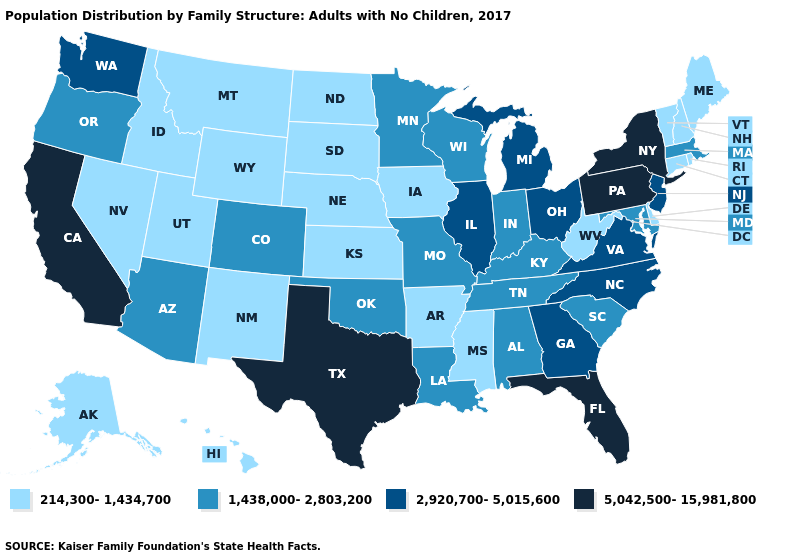Which states hav the highest value in the Northeast?
Give a very brief answer. New York, Pennsylvania. Does Illinois have a lower value than South Dakota?
Give a very brief answer. No. What is the lowest value in the MidWest?
Quick response, please. 214,300-1,434,700. What is the highest value in states that border Oklahoma?
Be succinct. 5,042,500-15,981,800. Name the states that have a value in the range 5,042,500-15,981,800?
Give a very brief answer. California, Florida, New York, Pennsylvania, Texas. Does Maine have the lowest value in the Northeast?
Write a very short answer. Yes. Does Maryland have the highest value in the USA?
Write a very short answer. No. Name the states that have a value in the range 214,300-1,434,700?
Give a very brief answer. Alaska, Arkansas, Connecticut, Delaware, Hawaii, Idaho, Iowa, Kansas, Maine, Mississippi, Montana, Nebraska, Nevada, New Hampshire, New Mexico, North Dakota, Rhode Island, South Dakota, Utah, Vermont, West Virginia, Wyoming. Among the states that border Wisconsin , which have the highest value?
Give a very brief answer. Illinois, Michigan. Does Virginia have a higher value than Nebraska?
Keep it brief. Yes. Is the legend a continuous bar?
Quick response, please. No. Does the map have missing data?
Quick response, please. No. What is the lowest value in the USA?
Write a very short answer. 214,300-1,434,700. Among the states that border North Dakota , which have the highest value?
Write a very short answer. Minnesota. What is the highest value in the USA?
Short answer required. 5,042,500-15,981,800. 